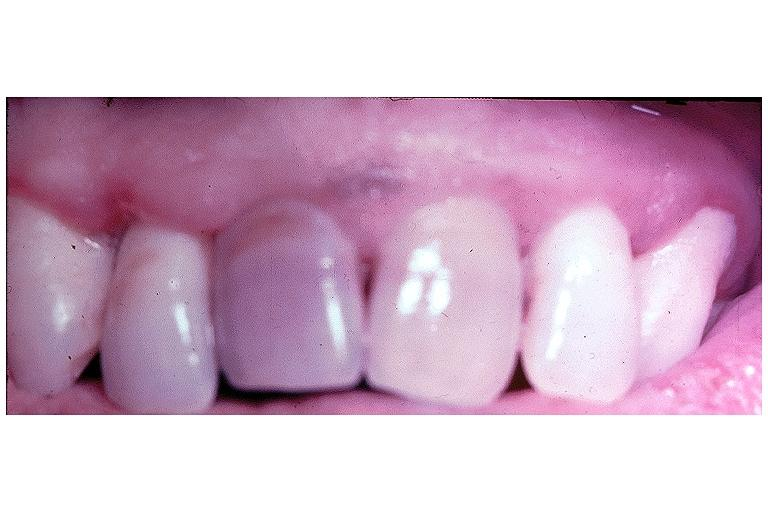what is present?
Answer the question using a single word or phrase. Oral 